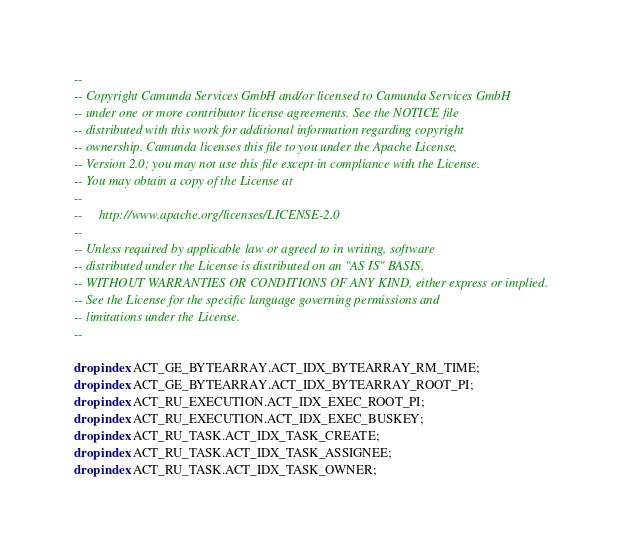Convert code to text. <code><loc_0><loc_0><loc_500><loc_500><_SQL_>--
-- Copyright Camunda Services GmbH and/or licensed to Camunda Services GmbH
-- under one or more contributor license agreements. See the NOTICE file
-- distributed with this work for additional information regarding copyright
-- ownership. Camunda licenses this file to you under the Apache License,
-- Version 2.0; you may not use this file except in compliance with the License.
-- You may obtain a copy of the License at
--
--     http://www.apache.org/licenses/LICENSE-2.0
--
-- Unless required by applicable law or agreed to in writing, software
-- distributed under the License is distributed on an "AS IS" BASIS,
-- WITHOUT WARRANTIES OR CONDITIONS OF ANY KIND, either express or implied.
-- See the License for the specific language governing permissions and
-- limitations under the License.
--

drop index ACT_GE_BYTEARRAY.ACT_IDX_BYTEARRAY_RM_TIME;
drop index ACT_GE_BYTEARRAY.ACT_IDX_BYTEARRAY_ROOT_PI;
drop index ACT_RU_EXECUTION.ACT_IDX_EXEC_ROOT_PI;
drop index ACT_RU_EXECUTION.ACT_IDX_EXEC_BUSKEY;
drop index ACT_RU_TASK.ACT_IDX_TASK_CREATE;
drop index ACT_RU_TASK.ACT_IDX_TASK_ASSIGNEE;
drop index ACT_RU_TASK.ACT_IDX_TASK_OWNER;</code> 